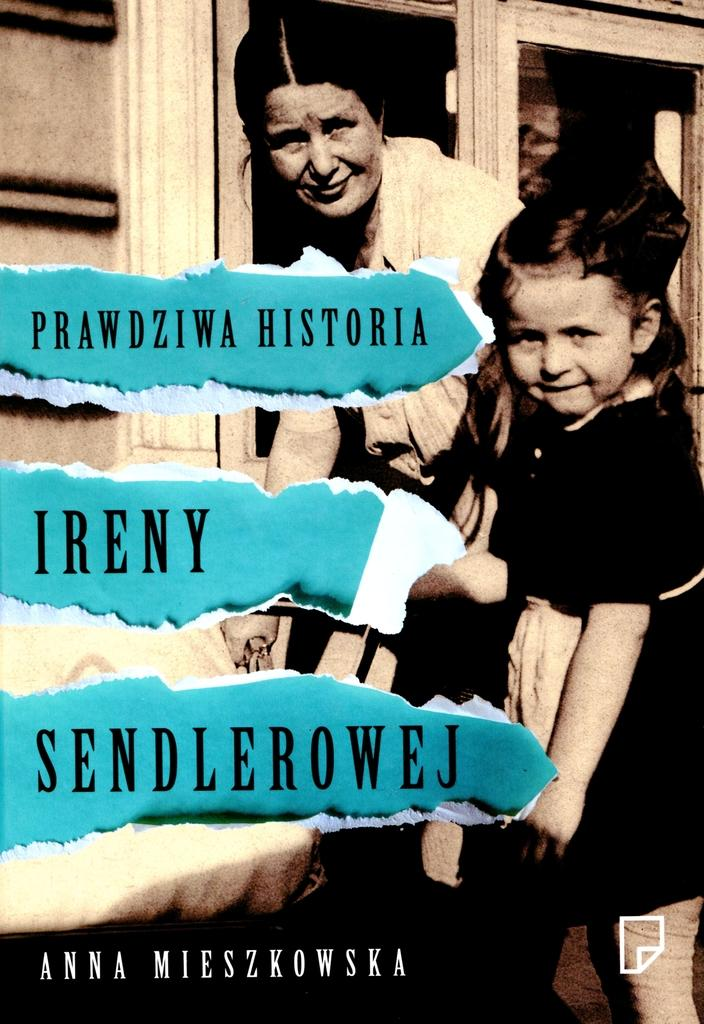Who are the people in the image? There is a girl and a woman in the image. What expressions do the girl and the woman have? Both the girl and the woman are smiling in the image. What else can be seen in the image besides the people? There is text visible in the image. How many frogs are sitting on the quilt in the image? There are no frogs or quilts present in the image. What type of twist can be seen in the image? There is no twist visible in the image. 